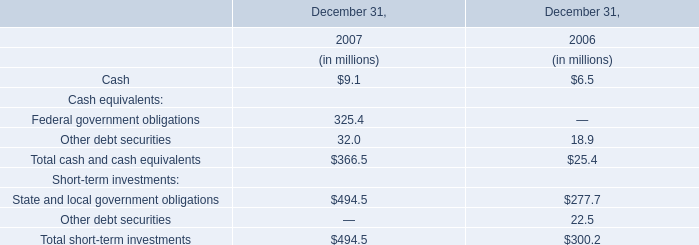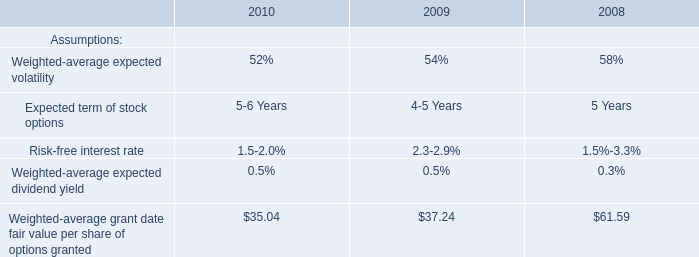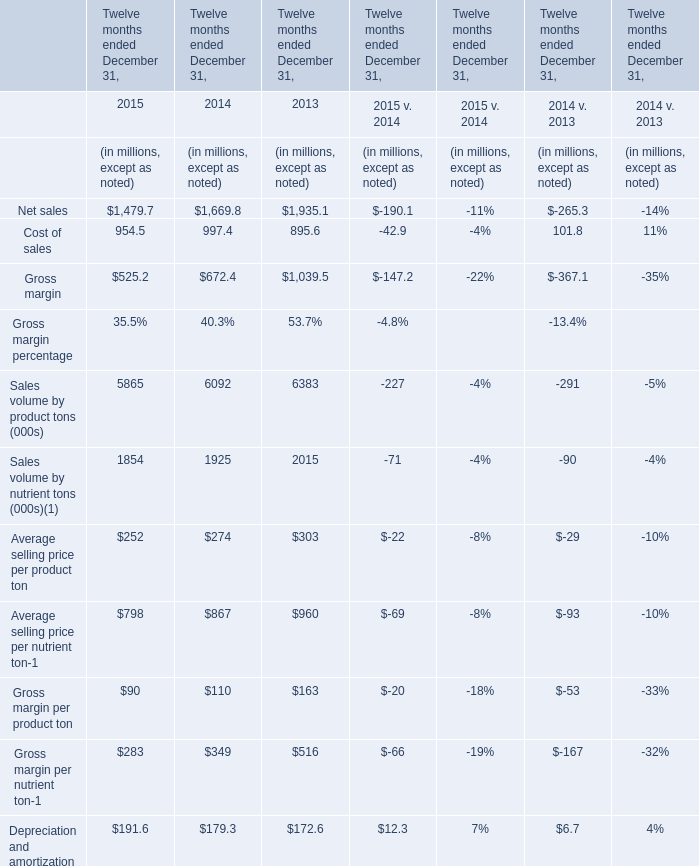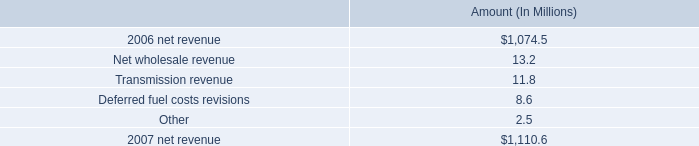what is the percent change in net revenue between 2006 and 2007? 
Computations: ((1074.5 - 1110.6) / 1110.6)
Answer: -0.0325. 